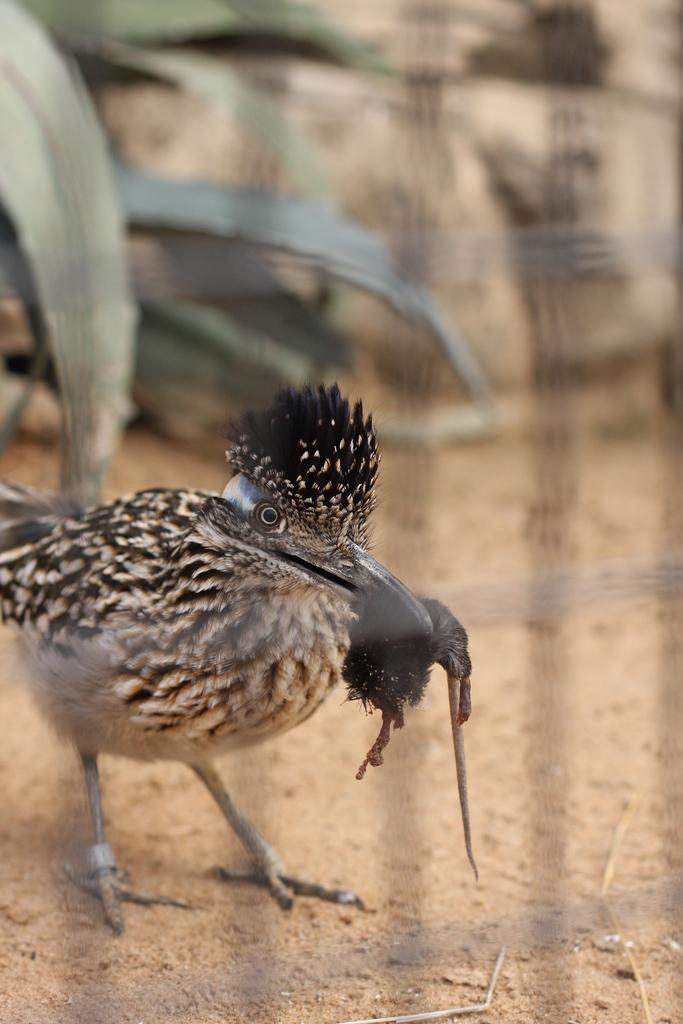Could you give a brief overview of what you see in this image? In this image, we can see a bird. There are leaves in the top left of the image. In the background, image is blurred. 